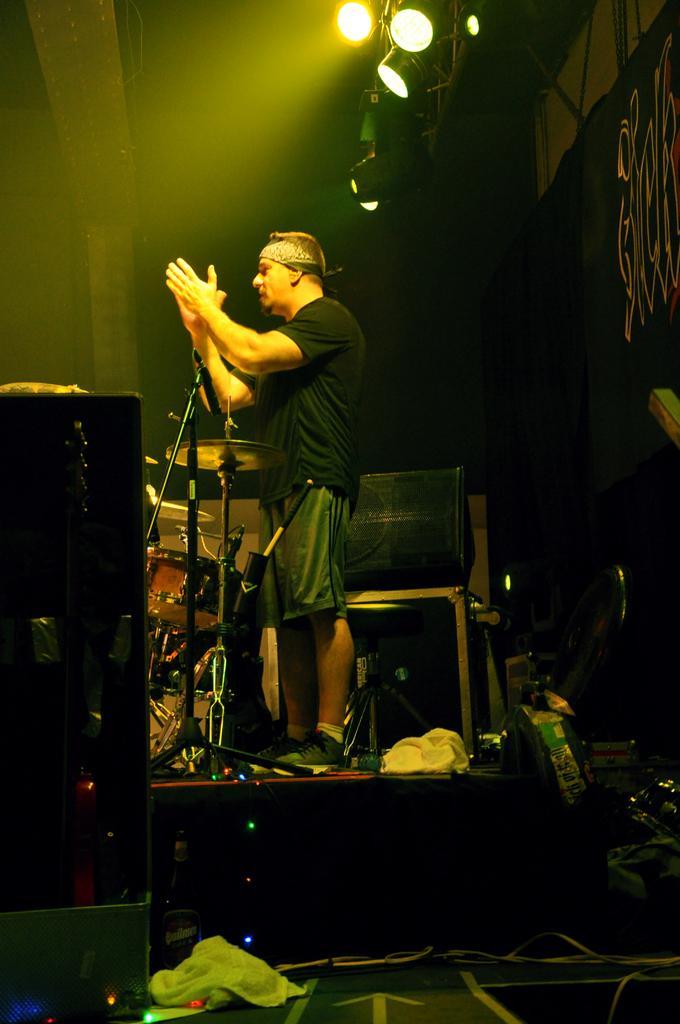Describe this image in one or two sentences. In the image we can see a man standing, wearing clothes, socks and shoes. These are the lights, stand, cable wires and musical instruments. 